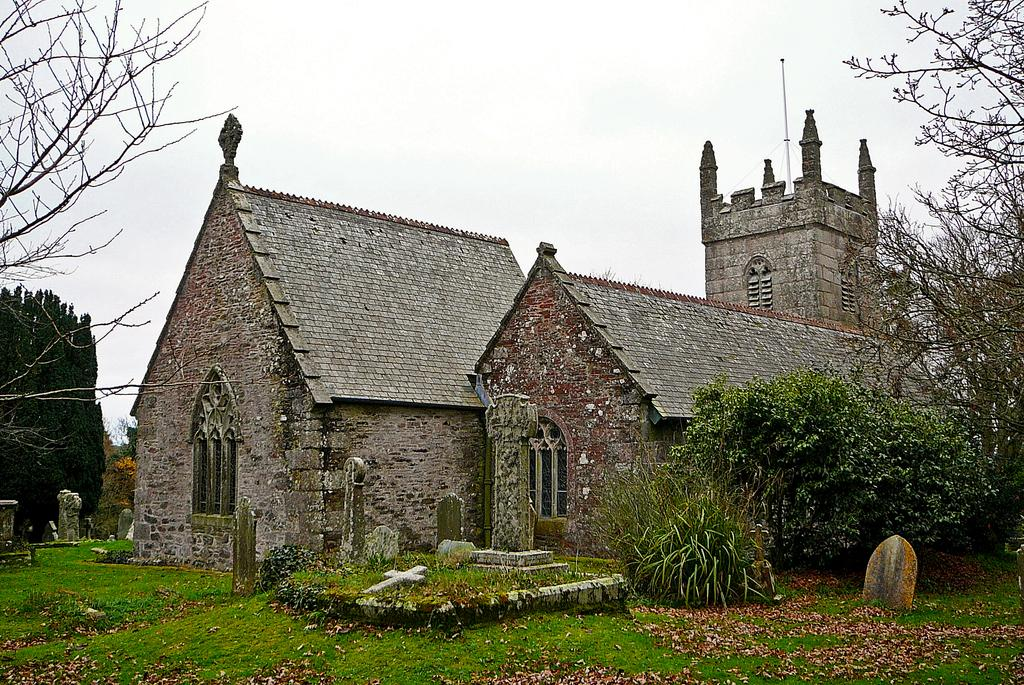What type of structure is present in the image? There is a building in the image. What color is the building? The building is brown. What other natural elements can be seen in the image? There are trees in the image. What color are the trees? The trees are green. What part of the environment is visible in the image? The sky is visible in the image. What color is the sky? The sky is white. What type of birds can be seen flying near the steel quartz in the image? There are no birds, steel, or quartz present in the image. 